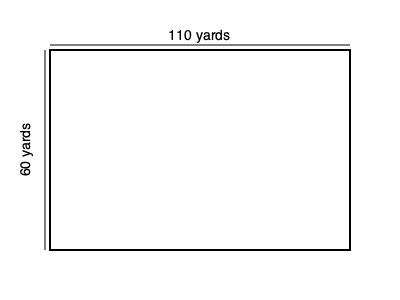You're helping to prepare the lacrosse field for an upcoming tournament in Charlotte. Given that a regulation lacrosse field measures 110 yards long and 60 yards wide, what is the total area of the field in square feet? To solve this problem, we need to follow these steps:

1. Identify the given dimensions:
   Length = 110 yards
   Width = 60 yards

2. Calculate the area using the formula for a rectangle:
   Area = Length × Width
   Area = 110 yards × 60 yards = 6,600 square yards

3. Convert square yards to square feet:
   1 yard = 3 feet, so 1 square yard = 3 × 3 = 9 square feet

4. Multiply the area in square yards by 9 to get square feet:
   Area in square feet = 6,600 × 9 = 59,400 square feet

Therefore, the total area of the lacrosse field is 59,400 square feet.
Answer: 59,400 sq ft 